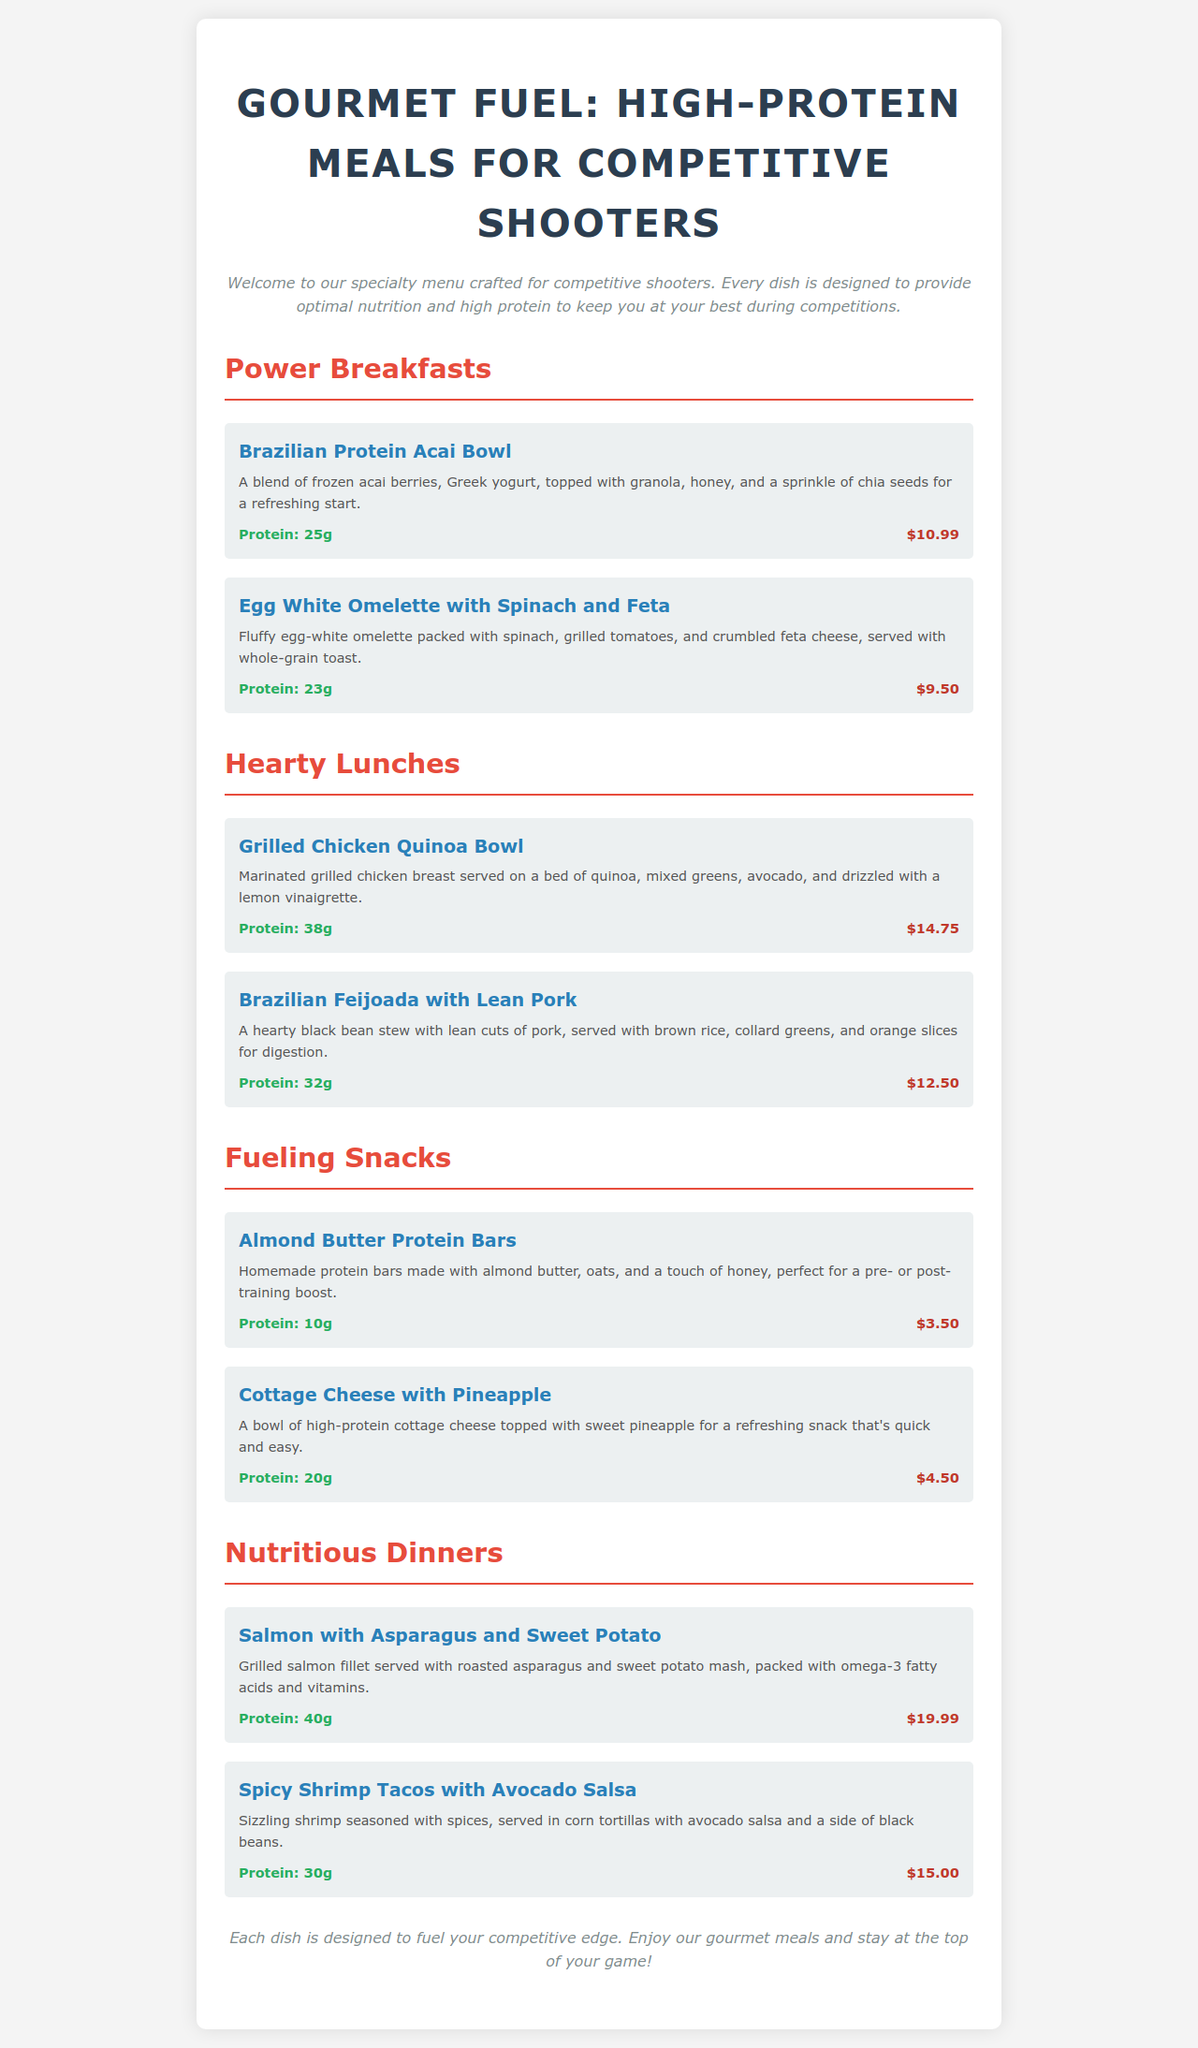What is the price of the Brazilian Protein Acai Bowl? The price for the Brazilian Protein Acai Bowl is stated in the menu under the item details.
Answer: $10.99 How much protein is in the Egg White Omelette with Spinach and Feta? The protein content for the Egg White Omelette is provided in the menu under the item details.
Answer: 23g What is the main ingredient in the Grilled Chicken Quinoa Bowl? The main ingredient in the Grilled Chicken Quinoa Bowl is specified in the item description of the menu.
Answer: Grilled chicken breast Which dish contains 40g of protein? The menu lists protein values and identifies dishes with their respective protein content.
Answer: Salmon with Asparagus and Sweet Potato What type of dish is the Brazilian Feijoada with Lean Pork? The category of the Brazilian Feijoada is noted in the section headings of the menu.
Answer: Hearty Lunch What is the total protein in the two Fueling Snacks options combined? The total protein can be calculated by adding the protein values of the two specified snacks in the menu.
Answer: 30g What is the price of the Cottage Cheese with Pineapple? The price for Cottage Cheese with Pineapple is provided in the menu under the item details.
Answer: $4.50 How many main categories are there in this menu? The number of categories is determined by counting the distinct sections in the menu.
Answer: Four 